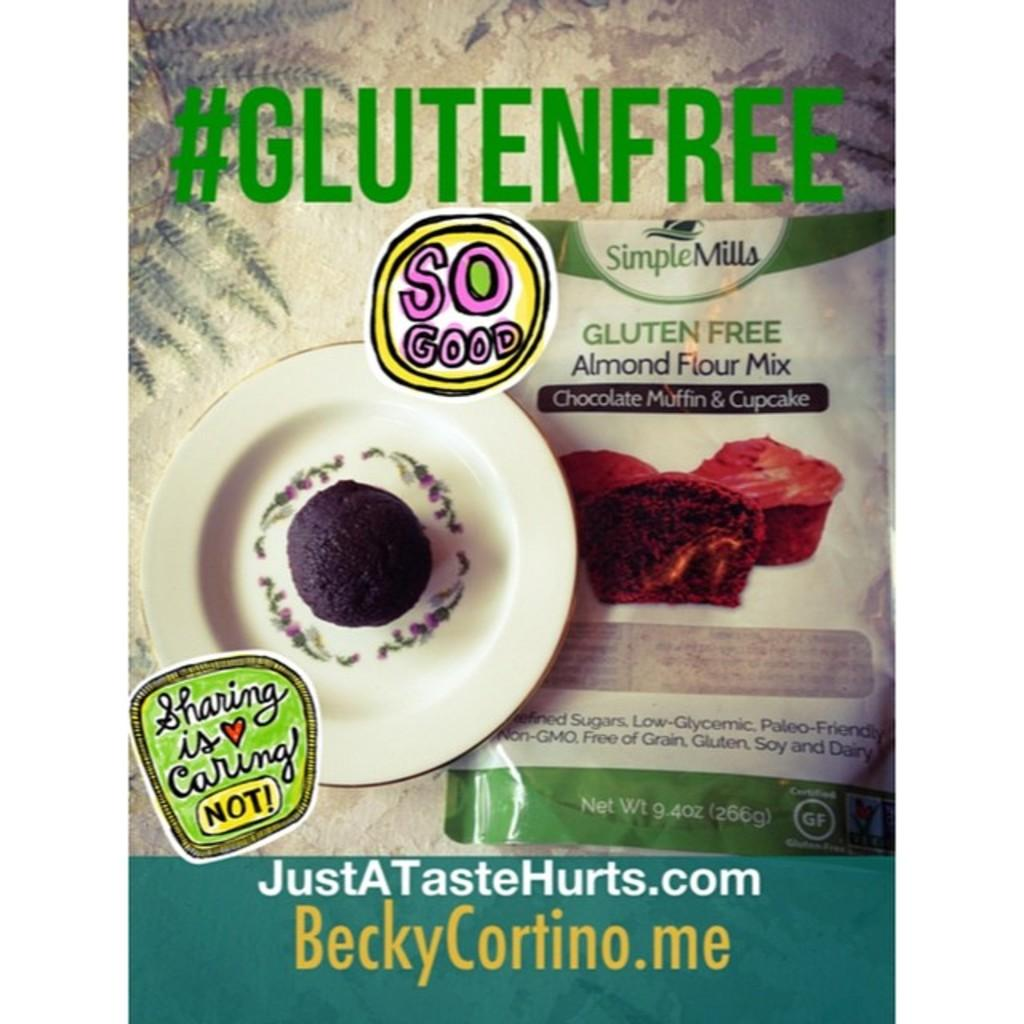What is located on the left side of the image? There is a cake on a plate on the left side of the image. What is on the right side of the image? There is a packet on the right side of the image. Can you describe anything in the background of the image? Yes, there is text visible in the background of the image. How many ladybugs can be seen crawling on the cake in the image? There are no ladybugs present in the image; it features a cake on a plate and a packet on the right side. What is the level of noise in the image? The image does not convey any information about the level of noise or sound; it only shows visual elements. 